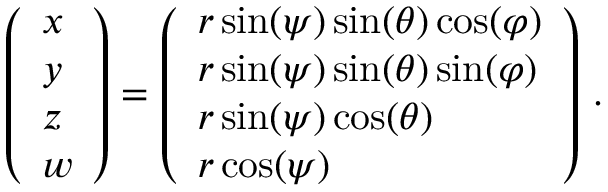Convert formula to latex. <formula><loc_0><loc_0><loc_500><loc_500>\left ( \begin{array} { l } { x } \\ { y } \\ { z } \\ { w } \end{array} \right ) = \left ( \begin{array} { l } { r \sin ( \psi ) \sin ( \theta ) \cos ( \varphi ) } \\ { r \sin ( \psi ) \sin ( \theta ) \sin ( \varphi ) } \\ { r \sin ( \psi ) \cos ( \theta ) } \\ { r \cos ( \psi ) } \end{array} \right ) \, .</formula> 